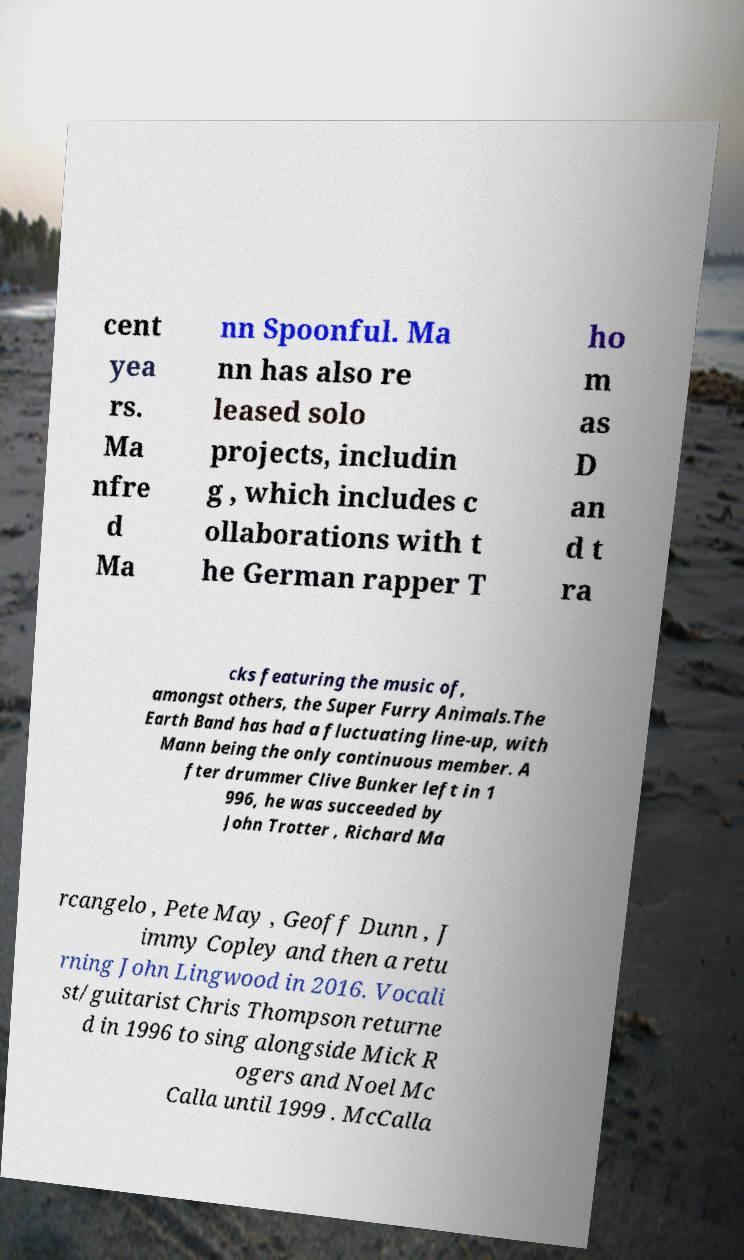What messages or text are displayed in this image? I need them in a readable, typed format. cent yea rs. Ma nfre d Ma nn Spoonful. Ma nn has also re leased solo projects, includin g , which includes c ollaborations with t he German rapper T ho m as D an d t ra cks featuring the music of, amongst others, the Super Furry Animals.The Earth Band has had a fluctuating line-up, with Mann being the only continuous member. A fter drummer Clive Bunker left in 1 996, he was succeeded by John Trotter , Richard Ma rcangelo , Pete May , Geoff Dunn , J immy Copley and then a retu rning John Lingwood in 2016. Vocali st/guitarist Chris Thompson returne d in 1996 to sing alongside Mick R ogers and Noel Mc Calla until 1999 . McCalla 